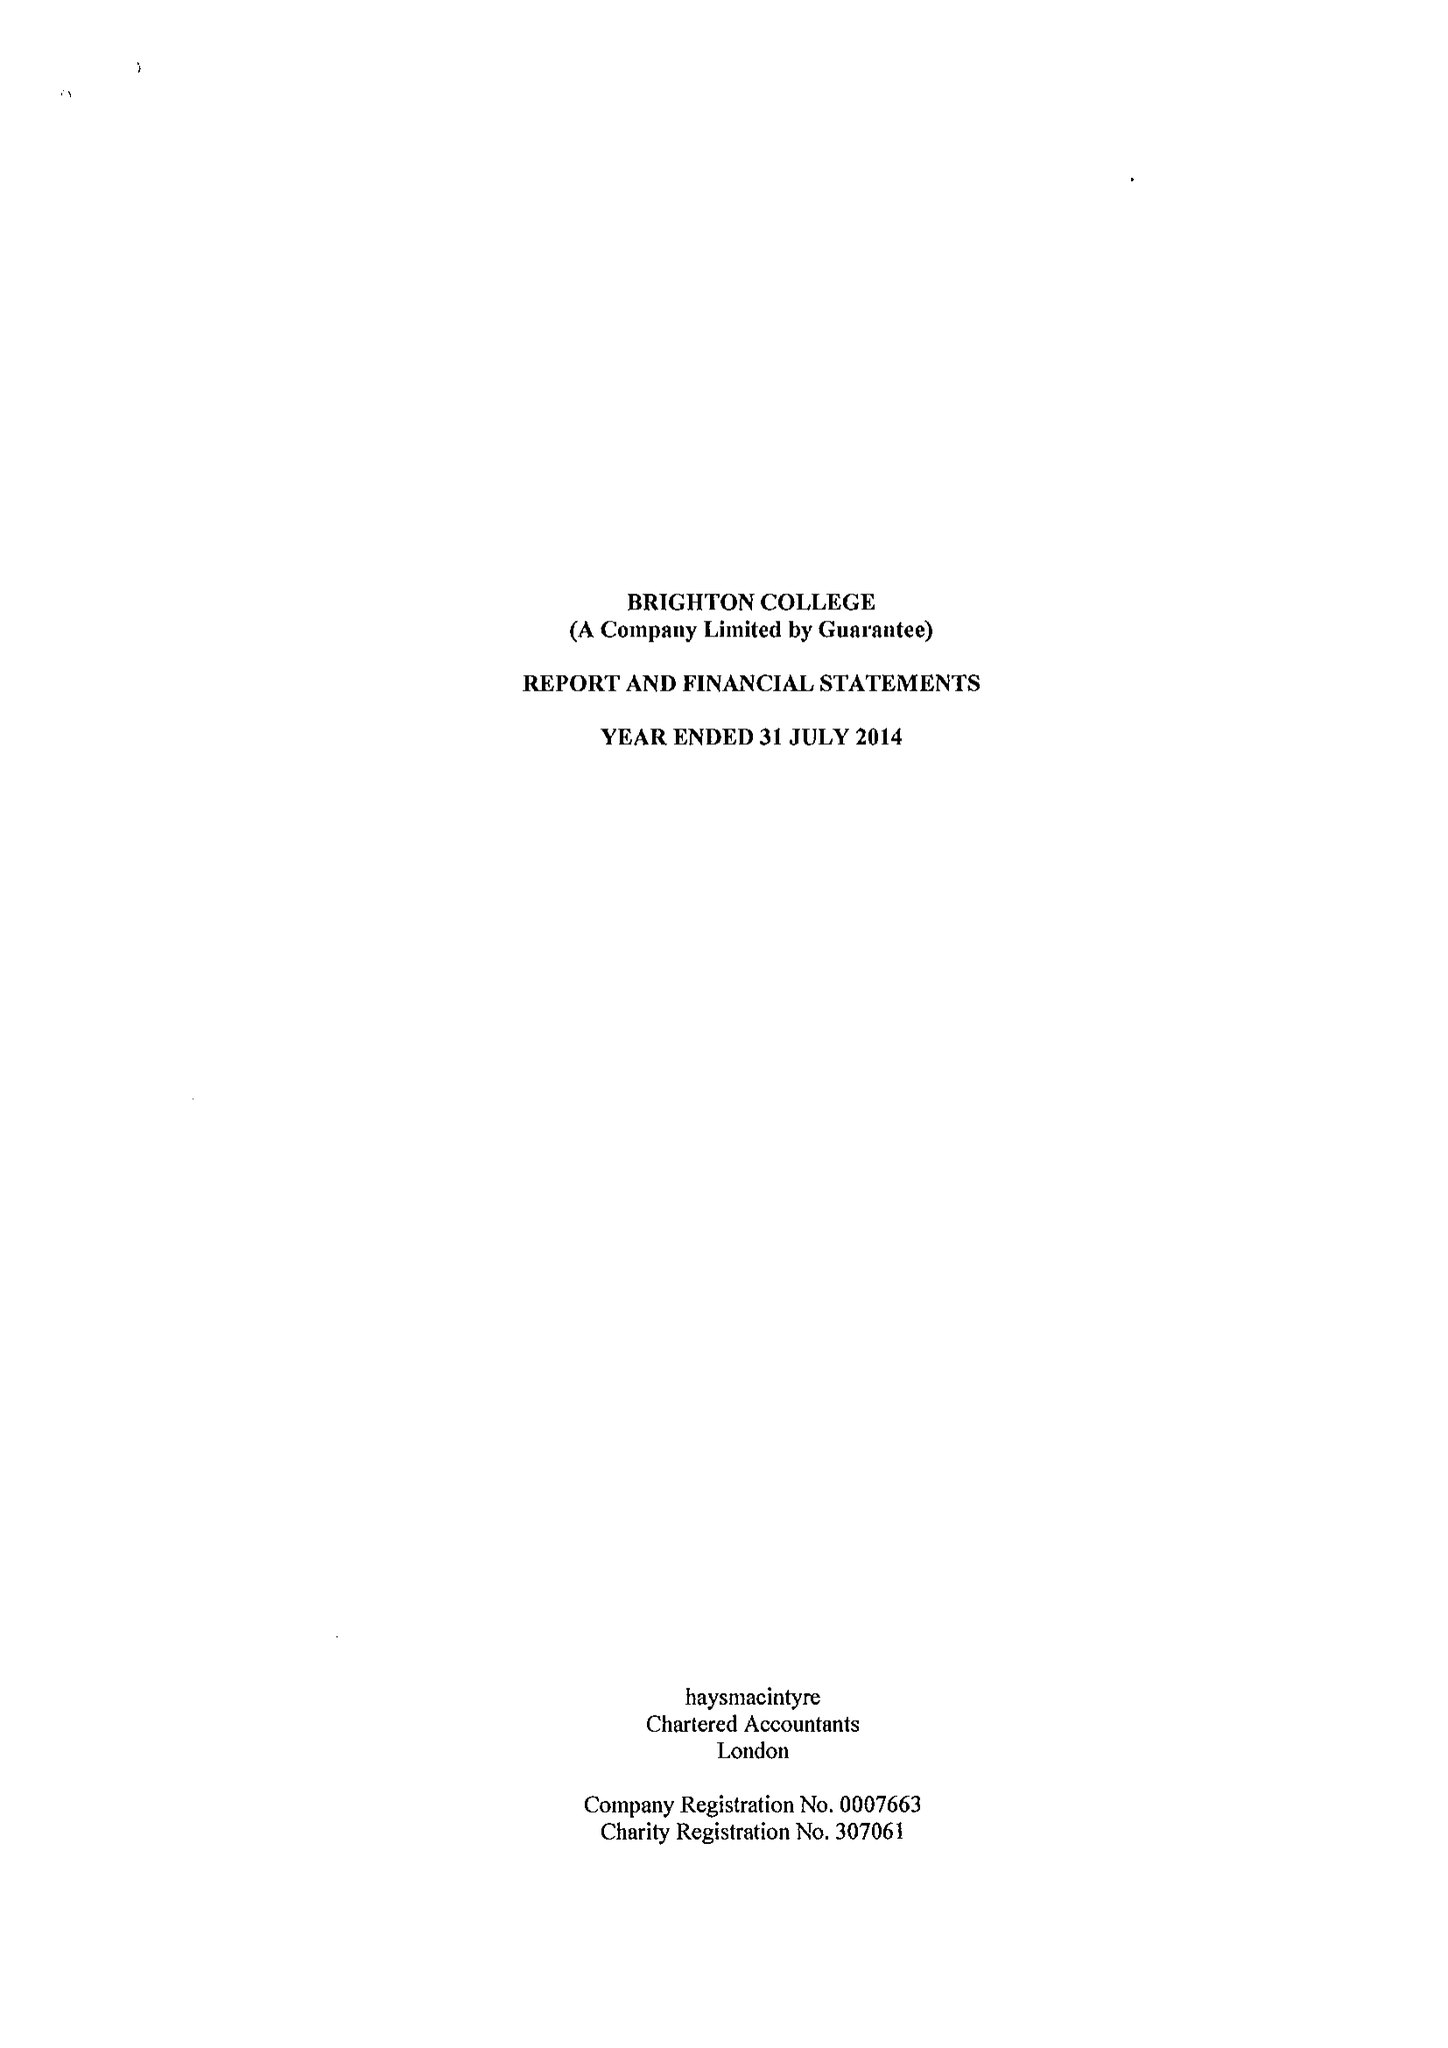What is the value for the income_annually_in_british_pounds?
Answer the question using a single word or phrase. 41018338.00 